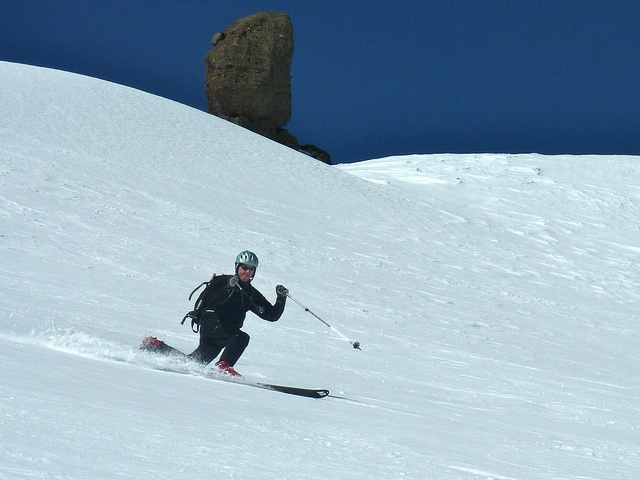Describe the objects in this image and their specific colors. I can see people in darkblue, black, gray, and lightblue tones, skis in darkblue, darkgray, black, and gray tones, backpack in darkblue, black, gray, and darkgray tones, and backpack in darkblue, black, navy, and lightgray tones in this image. 